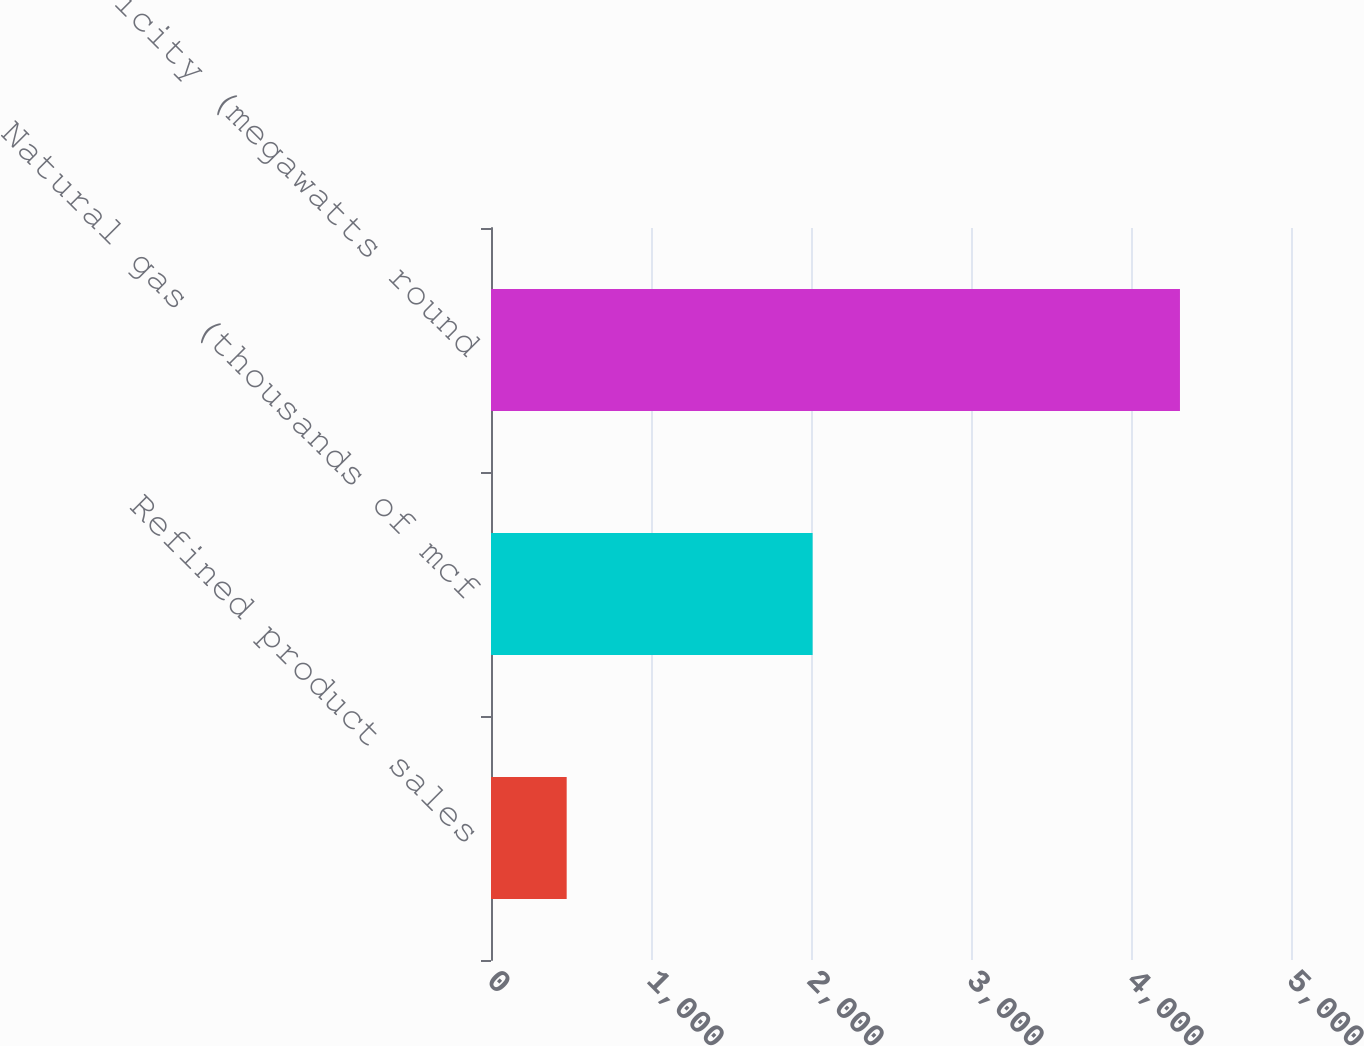<chart> <loc_0><loc_0><loc_500><loc_500><bar_chart><fcel>Refined product sales<fcel>Natural gas (thousands of mcf<fcel>Electricity (megawatts round<nl><fcel>473<fcel>2010<fcel>4306<nl></chart> 